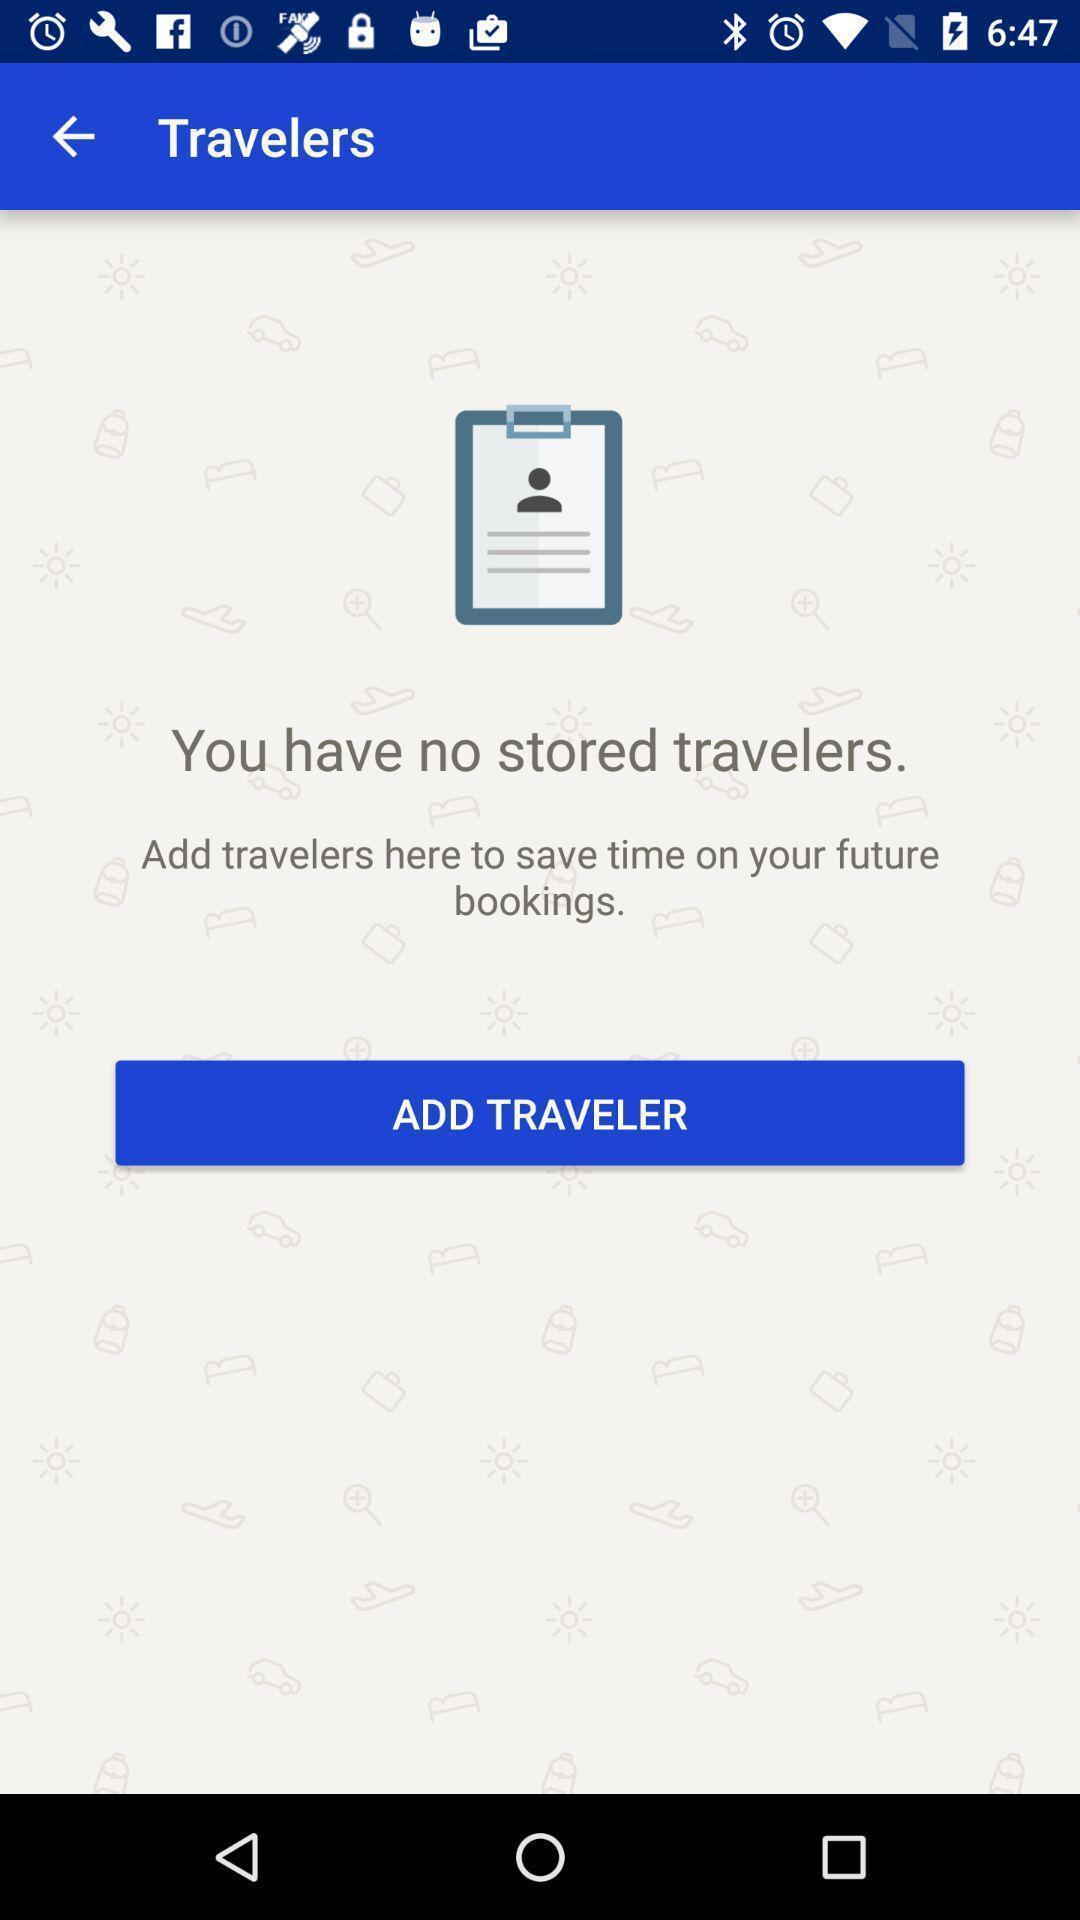Please provide a description for this image. Page showing add traveler. 